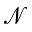<formula> <loc_0><loc_0><loc_500><loc_500>\mathcal { N }</formula> 